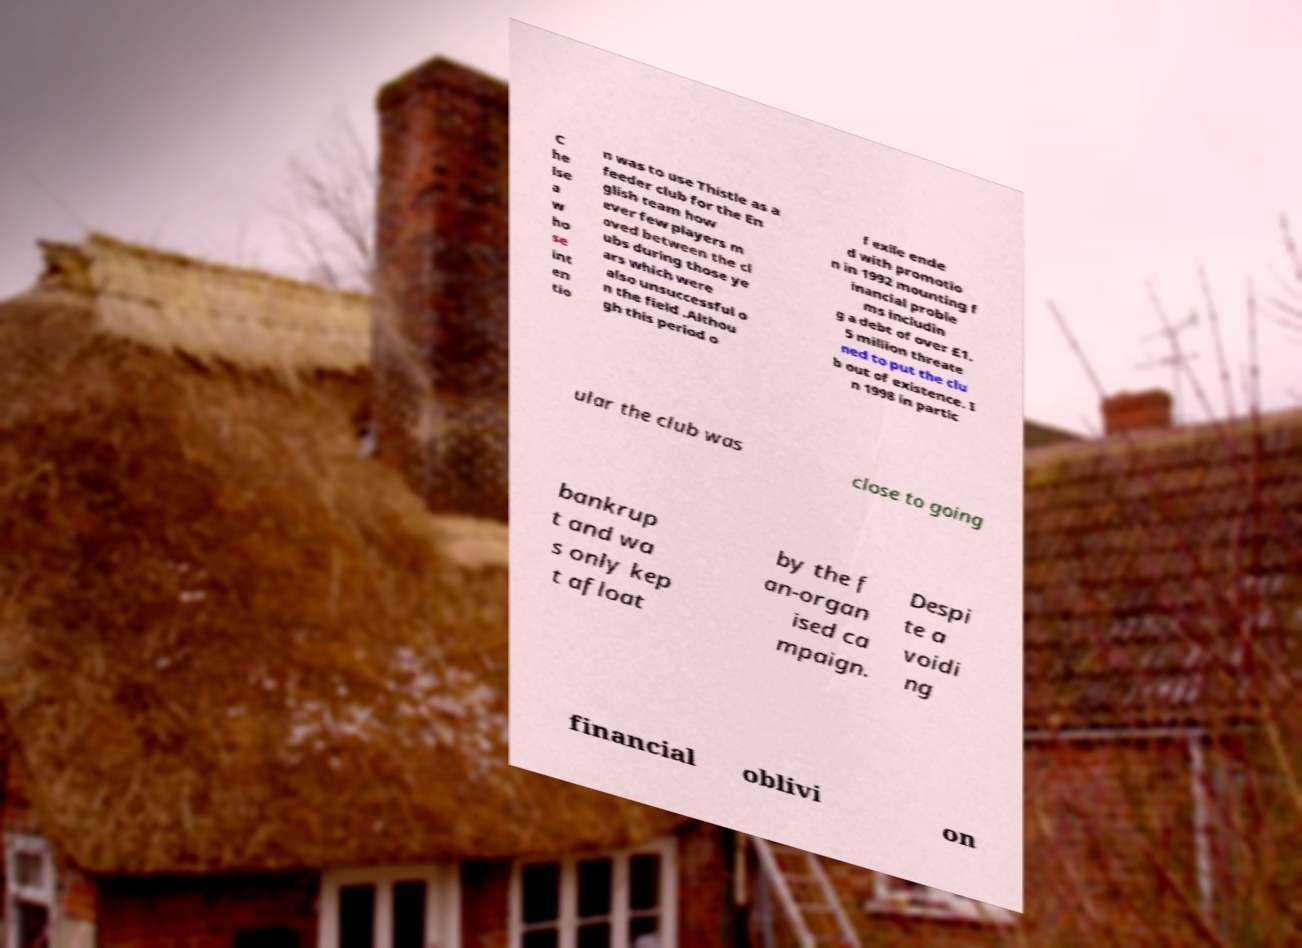Could you extract and type out the text from this image? C he lse a w ho se int en tio n was to use Thistle as a feeder club for the En glish team how ever few players m oved between the cl ubs during those ye ars which were also unsuccessful o n the field .Althou gh this period o f exile ende d with promotio n in 1992 mounting f inancial proble ms includin g a debt of over £1. 5 million threate ned to put the clu b out of existence. I n 1998 in partic ular the club was close to going bankrup t and wa s only kep t afloat by the f an-organ ised ca mpaign. Despi te a voidi ng financial oblivi on 